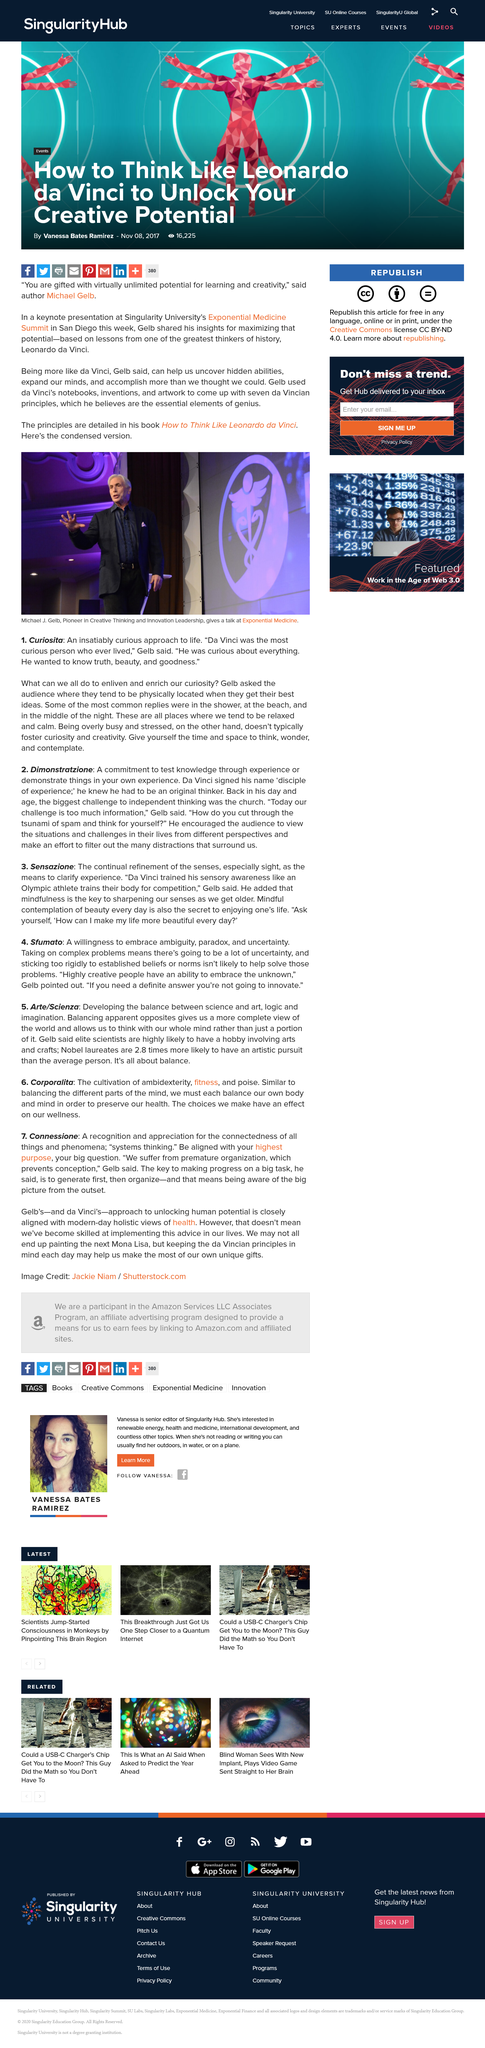Give some essential details in this illustration. Curiosita is a word that refers to a person's insatiable and persistent desire to learn and explore new things, often characterized by a sense of wonder and fascination with the world around them. It is widely believed that people tend to find their best ideas in places and at times where they are relaxed and calm, such as in the shower, on the beach, or in the middle of the night. Da Vinci sought to uncover truth, beauty, and goodness in his pursuits. 